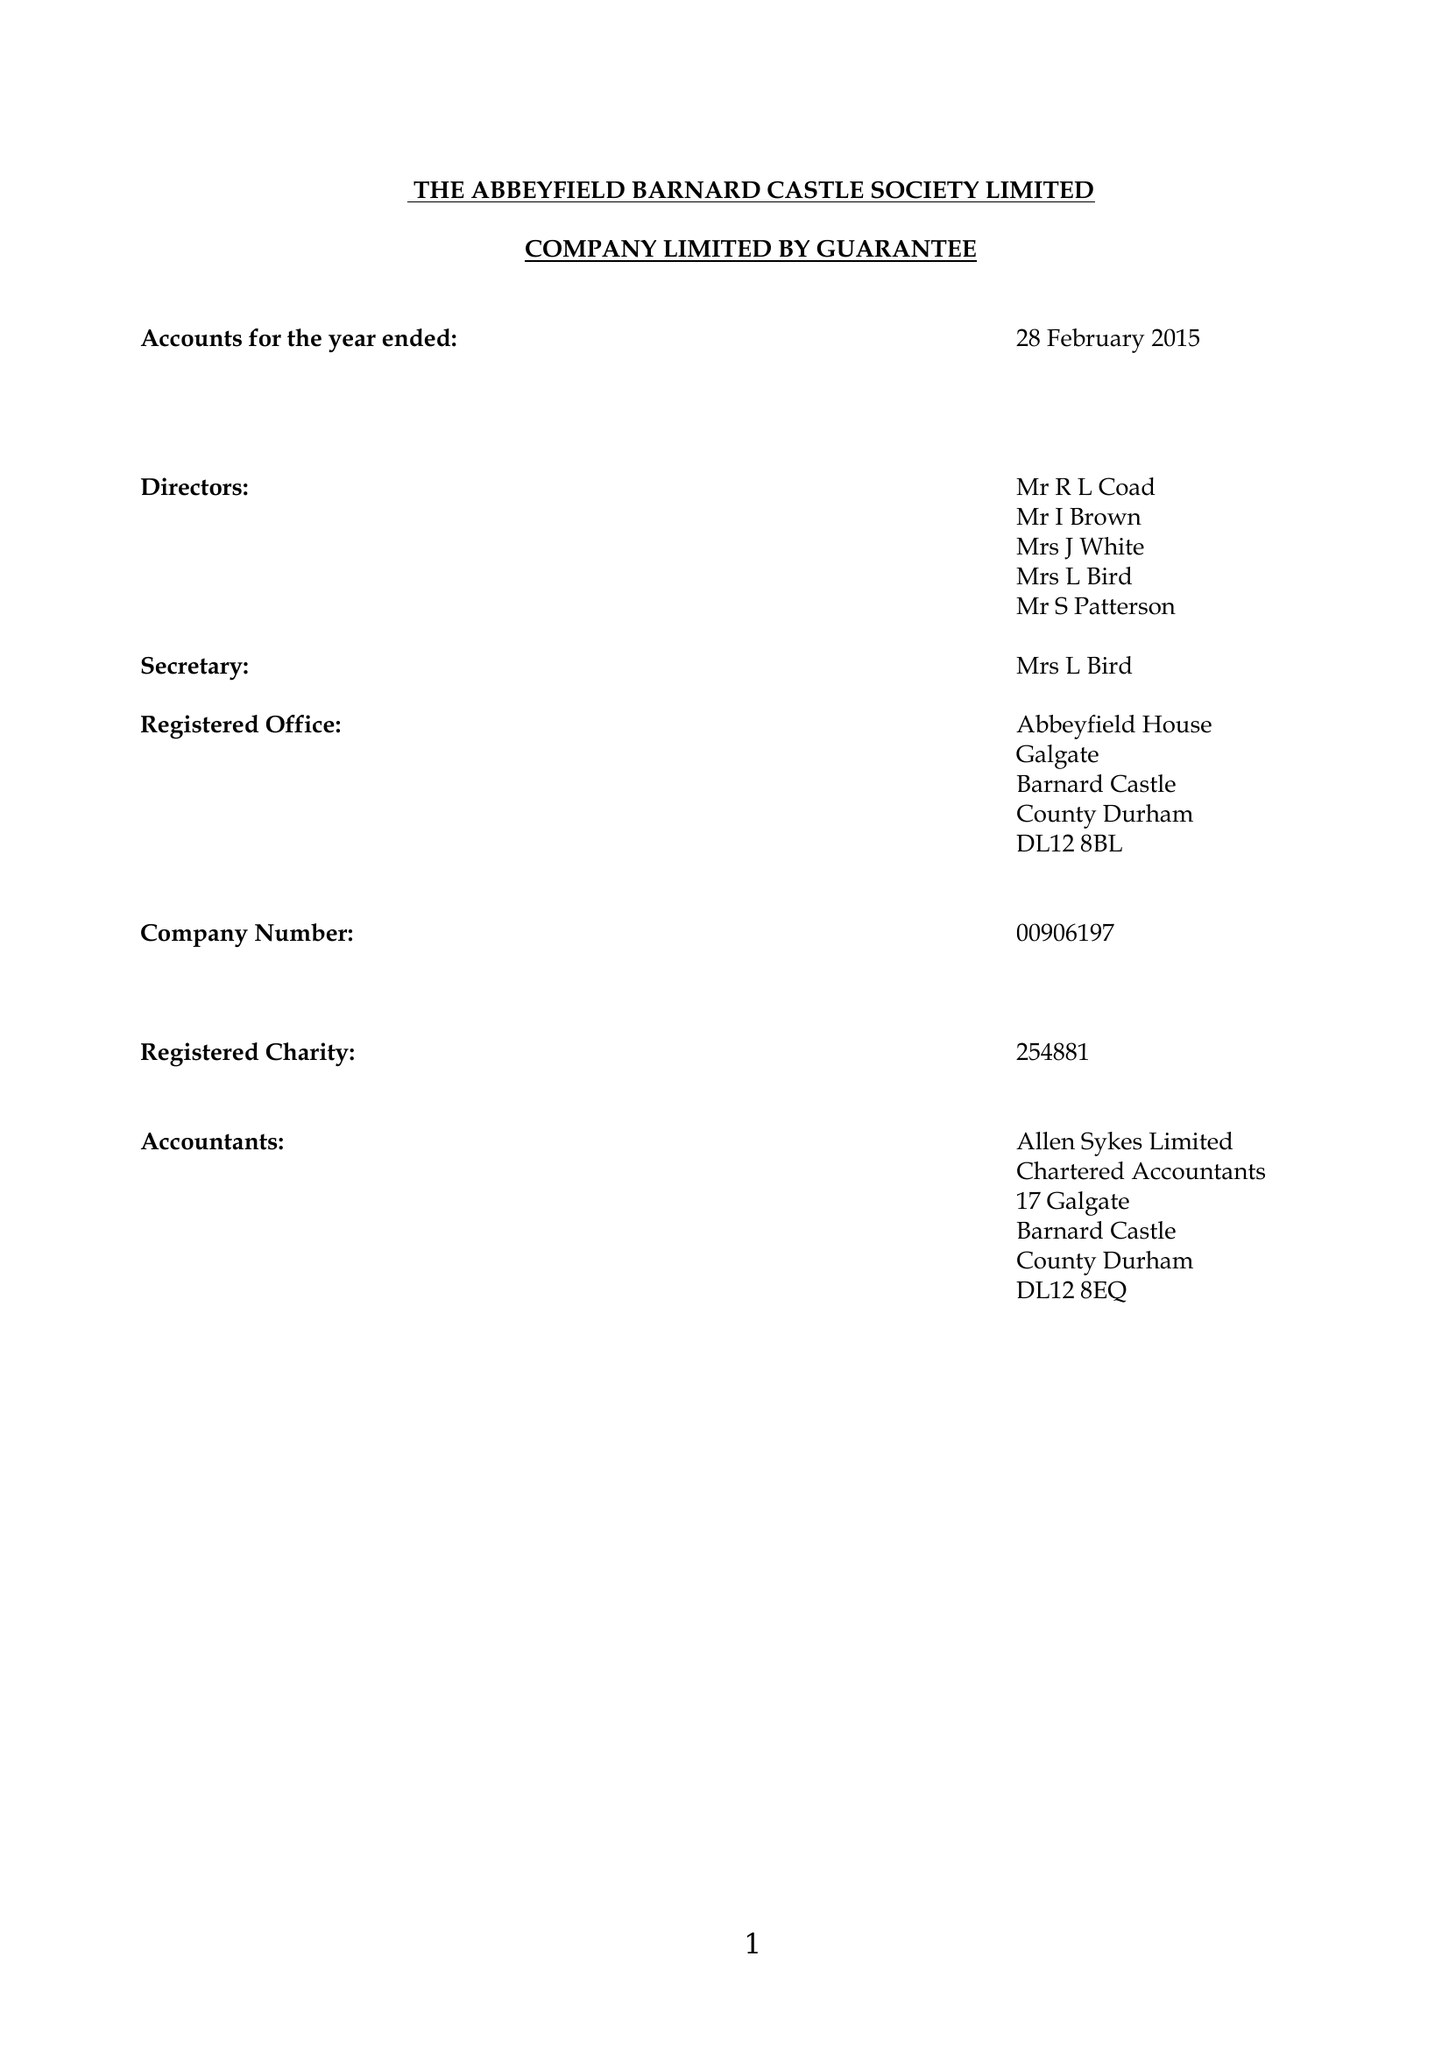What is the value for the spending_annually_in_british_pounds?
Answer the question using a single word or phrase. 139464.00 